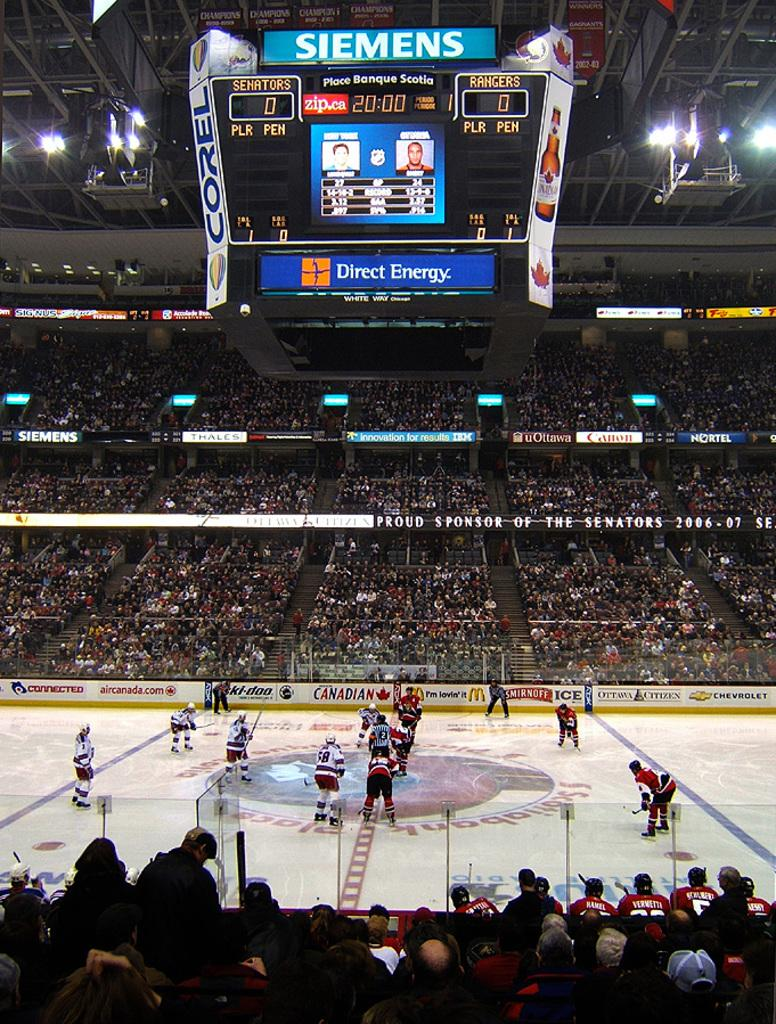<image>
Give a short and clear explanation of the subsequent image. A hockey game inside an arena with a Siemens scoreboard hanging above the rink. 